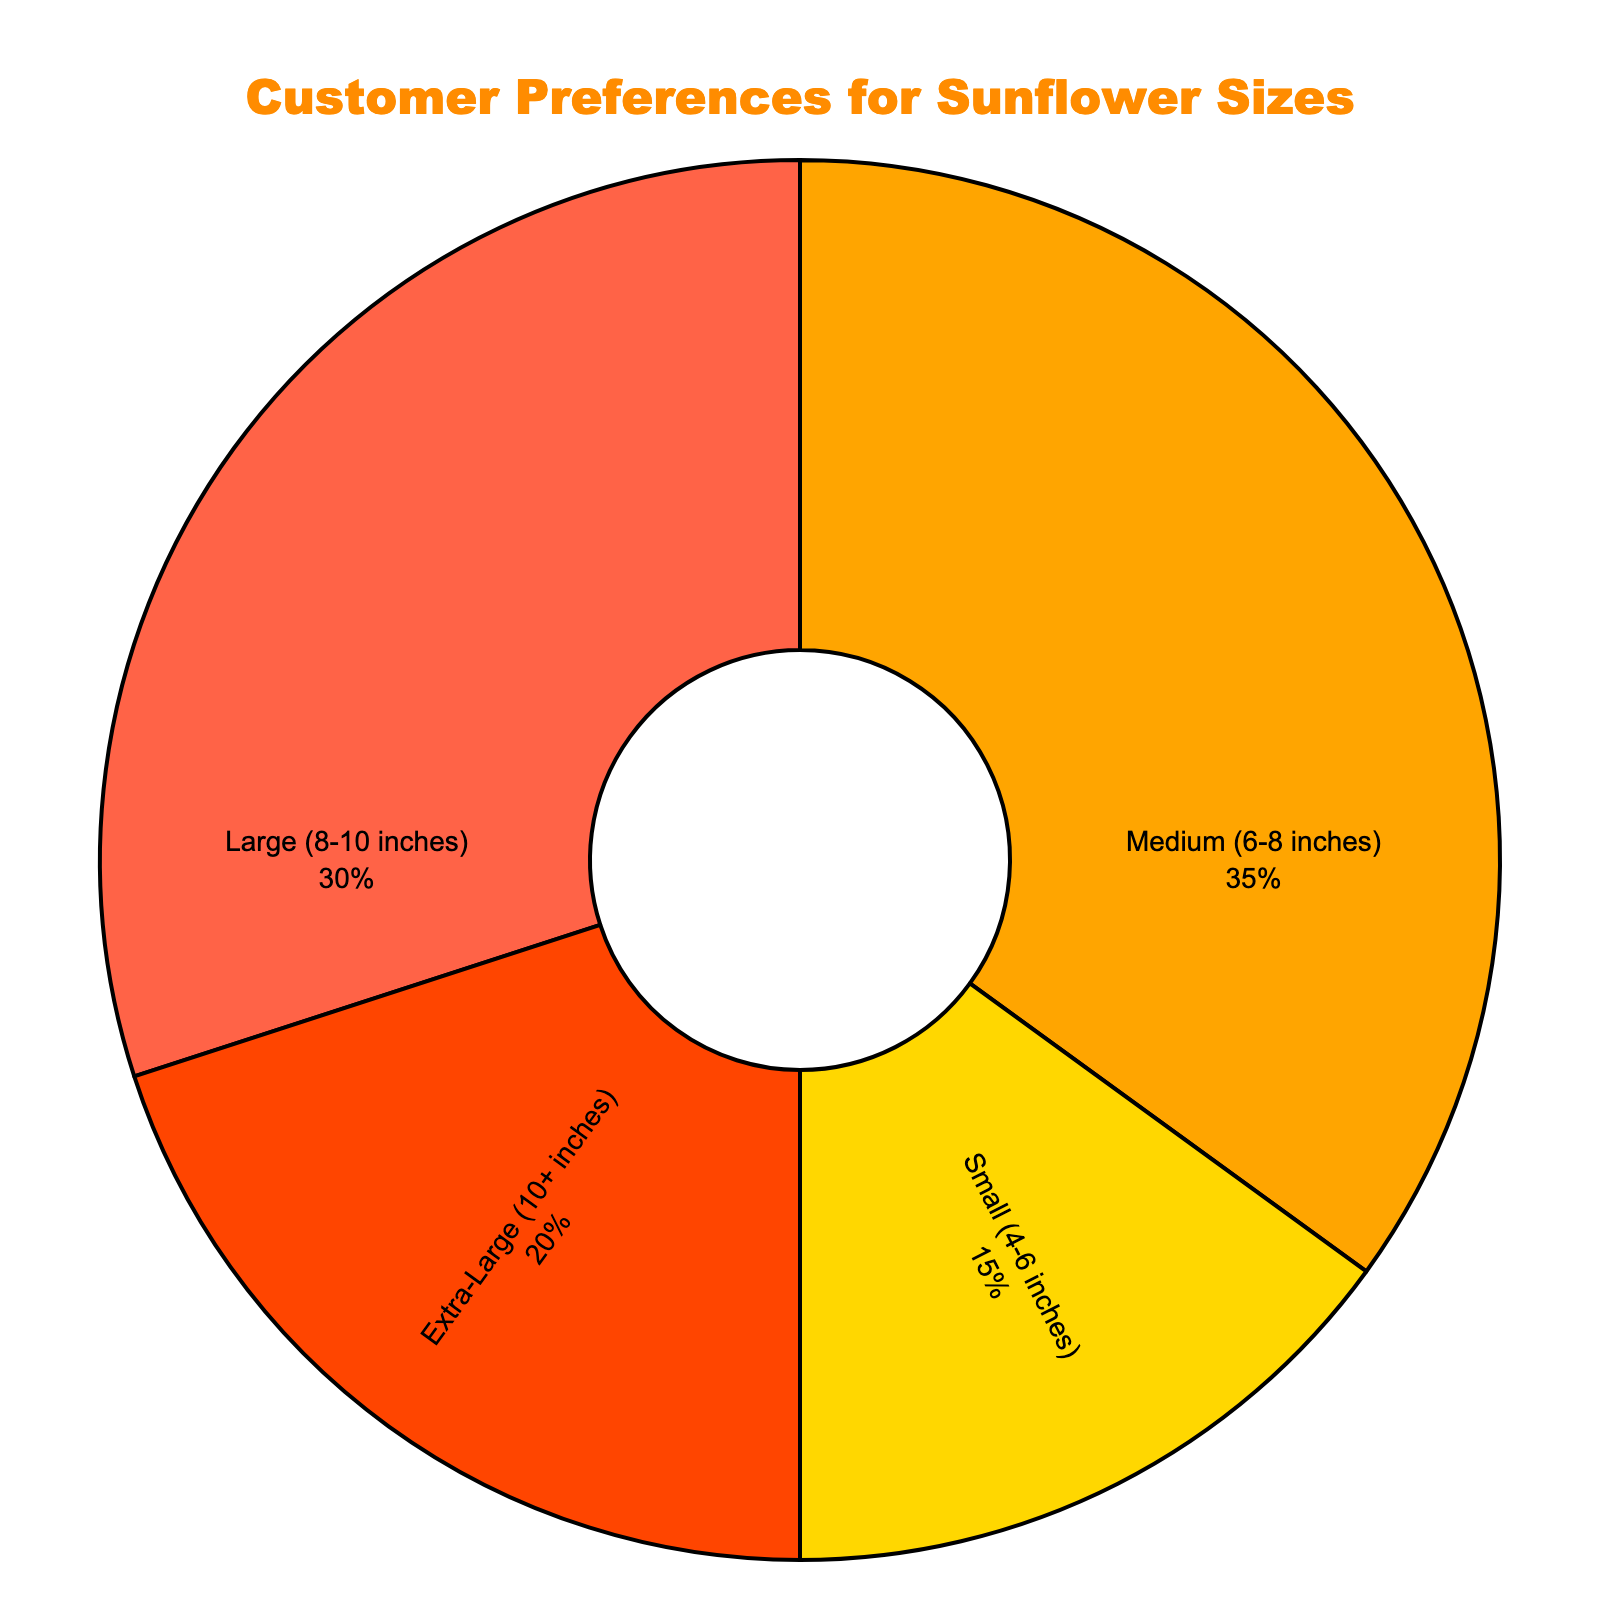What percentage of customers prefer medium-sized sunflowers? Referring to the figure, the slice labeled "Medium (6-8 inches)" has a percentage value attached. This percentage is 35%.
Answer: 35% Which size has the least customer preference? By examining the slices in the pie chart, the slice labeled "Small (4-6 inches)" has the smallest percentage value, which is 15%.
Answer: Small (4-6 inches) Compare the preferences between large and extra-large sunflowers. Which is more preferred and by how much? The figure shows that "Large (8-10 inches)" has a percentage of 30%, while "Extra-Large (10+ inches)" has 20%. The difference between them is 30% - 20% = 10%.
Answer: Large (8-10 inches) by 10% What is the combined preference percentage for small and extra-large sunflowers? The percentage for "Small (4-6 inches)" is 15% and for "Extra-Large (10+ inches)" is 20%. Adding these together gives 15% + 20% = 35%.
Answer: 35% Is the percentage of customers who prefer medium-sized sunflowers greater than the combined percentage of those who prefer small and extra-large sizes? The percentage for medium-sized sunflowers is 35%. The combined percentage for small and extra-large sizes is also 35%. Since 35% is equal to 35%, the two are equal.
Answer: No, they are equal What is the dominant color in the visual representation of the pie chart? The largest slice corresponds to "Medium (6-8 inches)" which is represented by a particular color. This color is orange.
Answer: Orange Which sizes account for half (50%) of the customer's preferences? Referring to the pie chart, "Medium (6-8 inches)" is 35%, and "Small (4-6 inches)" is 15%. Adding these gives 35% + 15% = 50%.
Answer: Medium (6-8 inches) and Small (4-6 inches) If customers' preference for large sunflowers increased by 5%, how would that affect its rank among the sizes? Currently, Large (8-10 inches) is 30%. Increasing it by 5% gives 30% + 5% = 35%, which equals the Medium (6-8 inches) percentage. Thus, it would tie for the most preferred size.
Answer: Tie for first Among the listed sunflower sizes, by how much does the preference percentage for medium sizes exceed the smallest preference percentage? The preferences for Medium (6-8 inches) and Small (4-6 inches) are 35% and 15% respectively. The difference is 35% - 15% = 20%.
Answer: 20% 